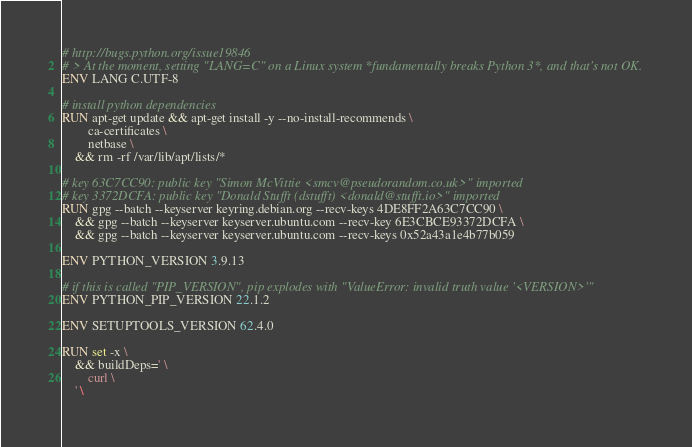Convert code to text. <code><loc_0><loc_0><loc_500><loc_500><_Dockerfile_>
# http://bugs.python.org/issue19846
# > At the moment, setting "LANG=C" on a Linux system *fundamentally breaks Python 3*, and that's not OK.
ENV LANG C.UTF-8

# install python dependencies
RUN apt-get update && apt-get install -y --no-install-recommends \
		ca-certificates \
		netbase \
	&& rm -rf /var/lib/apt/lists/*

# key 63C7CC90: public key "Simon McVittie <smcv@pseudorandom.co.uk>" imported
# key 3372DCFA: public key "Donald Stufft (dstufft) <donald@stufft.io>" imported
RUN gpg --batch --keyserver keyring.debian.org --recv-keys 4DE8FF2A63C7CC90 \
	&& gpg --batch --keyserver keyserver.ubuntu.com --recv-key 6E3CBCE93372DCFA \
	&& gpg --batch --keyserver keyserver.ubuntu.com --recv-keys 0x52a43a1e4b77b059

ENV PYTHON_VERSION 3.9.13

# if this is called "PIP_VERSION", pip explodes with "ValueError: invalid truth value '<VERSION>'"
ENV PYTHON_PIP_VERSION 22.1.2

ENV SETUPTOOLS_VERSION 62.4.0

RUN set -x \
	&& buildDeps=' \
		curl \
	' \</code> 